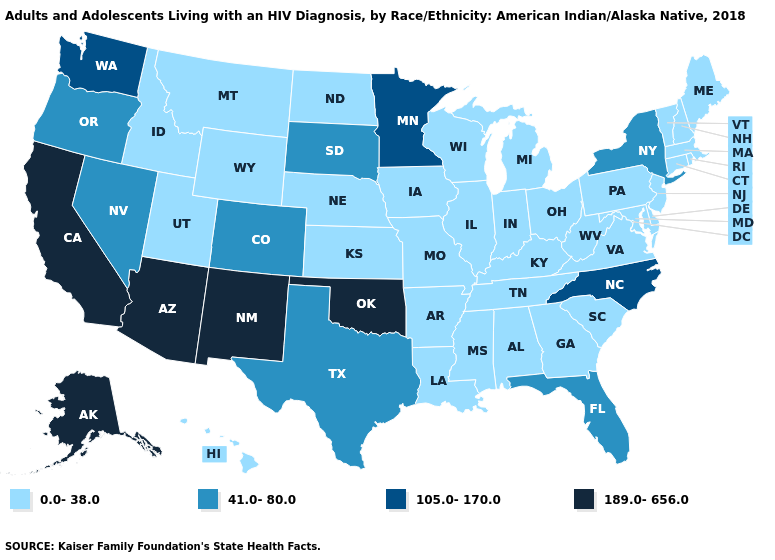Name the states that have a value in the range 41.0-80.0?
Short answer required. Colorado, Florida, Nevada, New York, Oregon, South Dakota, Texas. Does the map have missing data?
Short answer required. No. Does the map have missing data?
Keep it brief. No. Name the states that have a value in the range 0.0-38.0?
Be succinct. Alabama, Arkansas, Connecticut, Delaware, Georgia, Hawaii, Idaho, Illinois, Indiana, Iowa, Kansas, Kentucky, Louisiana, Maine, Maryland, Massachusetts, Michigan, Mississippi, Missouri, Montana, Nebraska, New Hampshire, New Jersey, North Dakota, Ohio, Pennsylvania, Rhode Island, South Carolina, Tennessee, Utah, Vermont, Virginia, West Virginia, Wisconsin, Wyoming. What is the value of Arizona?
Write a very short answer. 189.0-656.0. Name the states that have a value in the range 0.0-38.0?
Quick response, please. Alabama, Arkansas, Connecticut, Delaware, Georgia, Hawaii, Idaho, Illinois, Indiana, Iowa, Kansas, Kentucky, Louisiana, Maine, Maryland, Massachusetts, Michigan, Mississippi, Missouri, Montana, Nebraska, New Hampshire, New Jersey, North Dakota, Ohio, Pennsylvania, Rhode Island, South Carolina, Tennessee, Utah, Vermont, Virginia, West Virginia, Wisconsin, Wyoming. Name the states that have a value in the range 0.0-38.0?
Short answer required. Alabama, Arkansas, Connecticut, Delaware, Georgia, Hawaii, Idaho, Illinois, Indiana, Iowa, Kansas, Kentucky, Louisiana, Maine, Maryland, Massachusetts, Michigan, Mississippi, Missouri, Montana, Nebraska, New Hampshire, New Jersey, North Dakota, Ohio, Pennsylvania, Rhode Island, South Carolina, Tennessee, Utah, Vermont, Virginia, West Virginia, Wisconsin, Wyoming. Name the states that have a value in the range 105.0-170.0?
Quick response, please. Minnesota, North Carolina, Washington. Does Iowa have a higher value than Washington?
Quick response, please. No. Is the legend a continuous bar?
Concise answer only. No. Name the states that have a value in the range 189.0-656.0?
Write a very short answer. Alaska, Arizona, California, New Mexico, Oklahoma. What is the value of North Carolina?
Quick response, please. 105.0-170.0. Name the states that have a value in the range 105.0-170.0?
Short answer required. Minnesota, North Carolina, Washington. Which states have the lowest value in the MidWest?
Write a very short answer. Illinois, Indiana, Iowa, Kansas, Michigan, Missouri, Nebraska, North Dakota, Ohio, Wisconsin. What is the value of Texas?
Answer briefly. 41.0-80.0. 